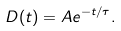Convert formula to latex. <formula><loc_0><loc_0><loc_500><loc_500>D ( t ) = A e ^ { - t / \tau } .</formula> 